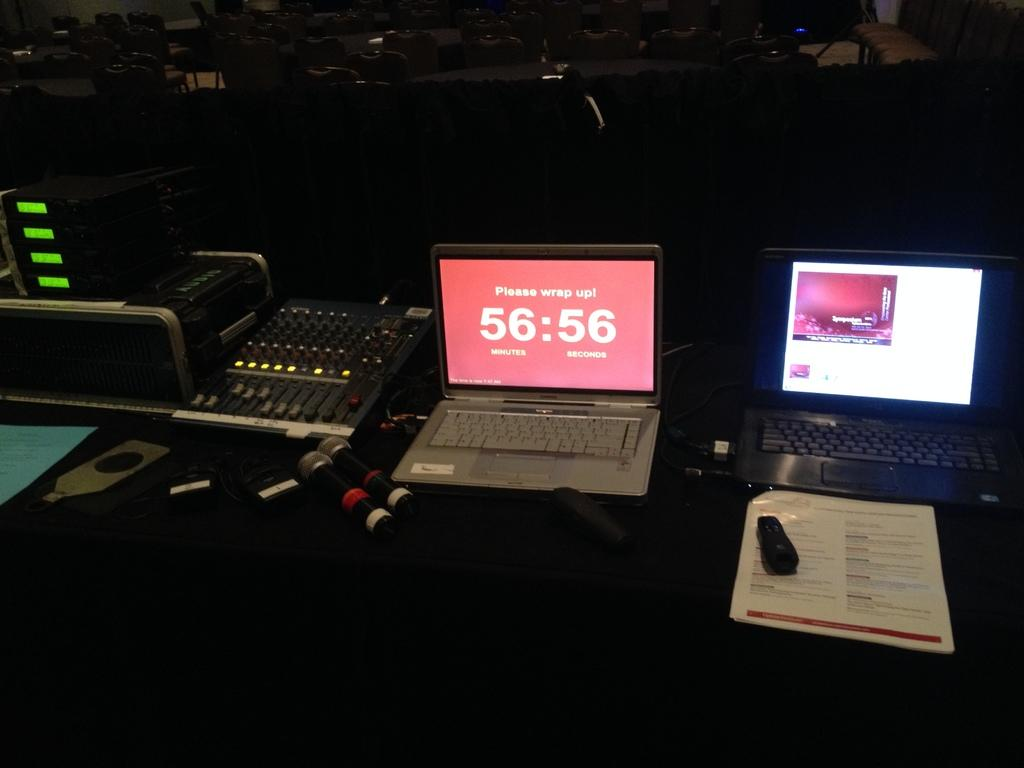<image>
Provide a brief description of the given image. Two laptops are open and one reads please wrap up in 56:56 